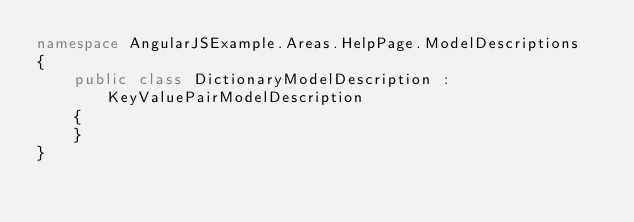Convert code to text. <code><loc_0><loc_0><loc_500><loc_500><_C#_>namespace AngularJSExample.Areas.HelpPage.ModelDescriptions
{
    public class DictionaryModelDescription : KeyValuePairModelDescription
    {
    }
}</code> 